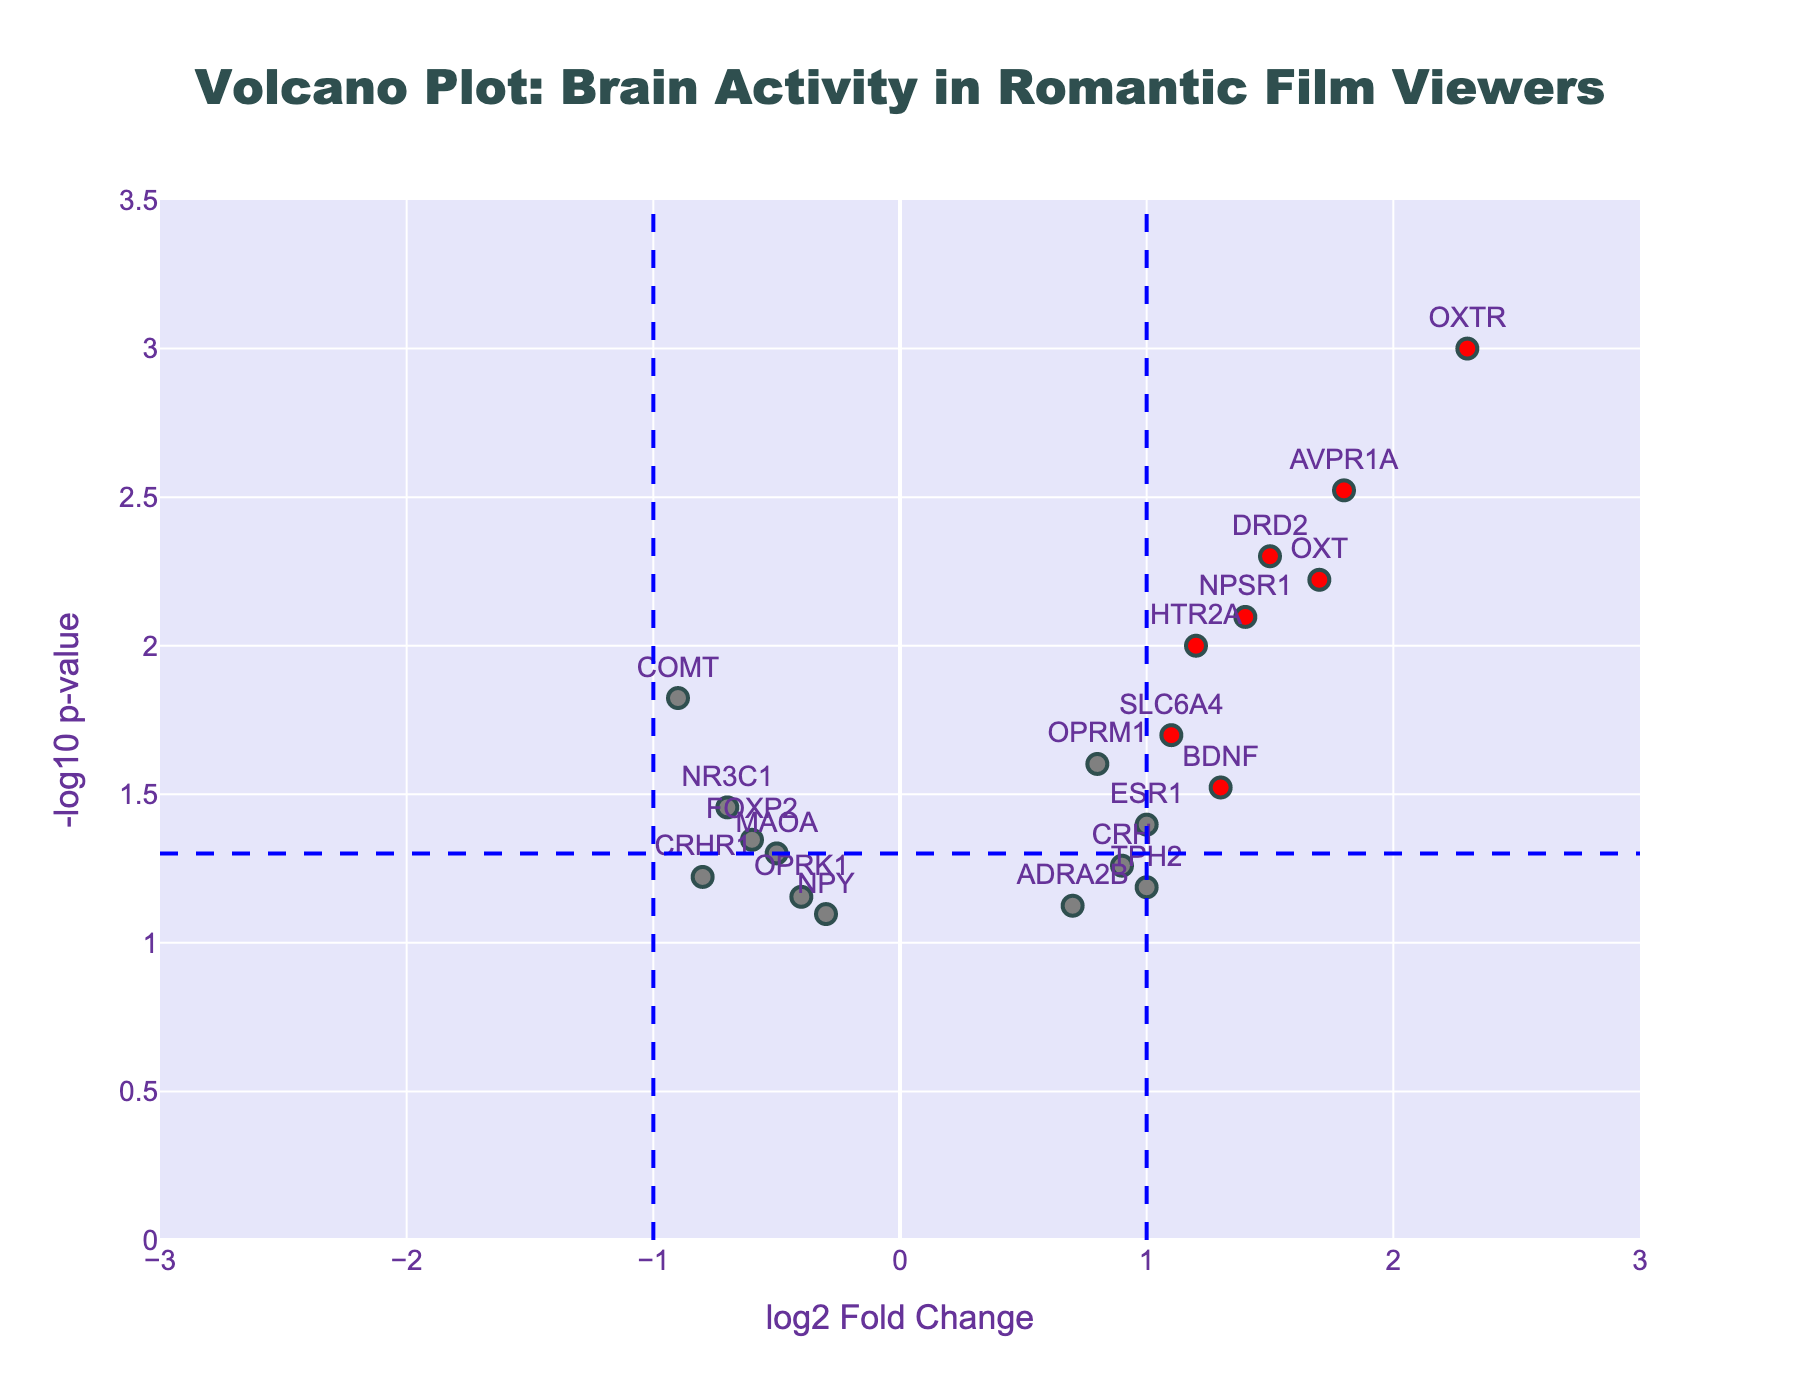What is the title of the plot? The title of the plot is displayed at the top of the figure. It helps to understand the context or the main focus of the plot.
Answer: "Volcano Plot: Brain Activity in Romantic Film Viewers" What are the axis labels? The x-axis label is given at the bottom of the plot while the y-axis label is found to the left. These labels provide context to the data represented on the axes.
Answer: x-axis: "log2 Fold Change", y-axis: "-log10 p-value" How many genes are significantly upregulated in romantic film viewers' brains? To find this, we look for red-colored points on the positive side of the x-axis that are above the blue horizontal line (-log10(0.05)).
Answer: 5 genes (OXTR, AVPR1A, OXT, NPSR1, DRD2) Which gene shows the highest fold change? To determine this, find the point farthest to the right on the x-axis. The fold change corresponds to the log2FoldChange value.
Answer: OXTR What does the color red signify in the plot? The red color indicates genes that have an absolute log2 fold change greater than 1 and a p-value less than 0.05, signifying statistically significant changes.
Answer: Statistically significant changes Are there any genes with a negative log2 fold change that are statistically significant? Look for red-colored points on the negative side of the x-axis above the blue horizontal line (-log10(0.05)).
Answer: No What is the p-value threshold used for significance? The p-value threshold is indicated by the horizontal blue dashed line on the plot, and it's common to use a threshold of 0.05.
Answer: 0.05 Which gene has the closest p-value to the significance threshold but is not significant? Look for a gene just below the blue horizontal line near the threshold of the y-axis value of -log10(0.05).
Answer: OPRM1 How many non-significant genes are displayed in the plot? To answer this, count the number of grey points in the plot, as they represent non-significant changes.
Answer: 12 genes Which genes have a p-value less than 0.01 and what are their log2 fold changes? Identify the genes whose y-values are above -log10(0.01) and list their respective x-values (log2 fold changes).
Answer: OXTR: 2.3, AVPR1A: 1.8, DRD2: 1.5, OXT: 1.7, NPSR1: 1.4 What is the log2 fold change for the gene with the smallest p-value? The smallest p-value corresponds to the highest y-value in the plot. Find the x-value (log2 fold change) for this point.
Answer: 2.3 (OXTR) 